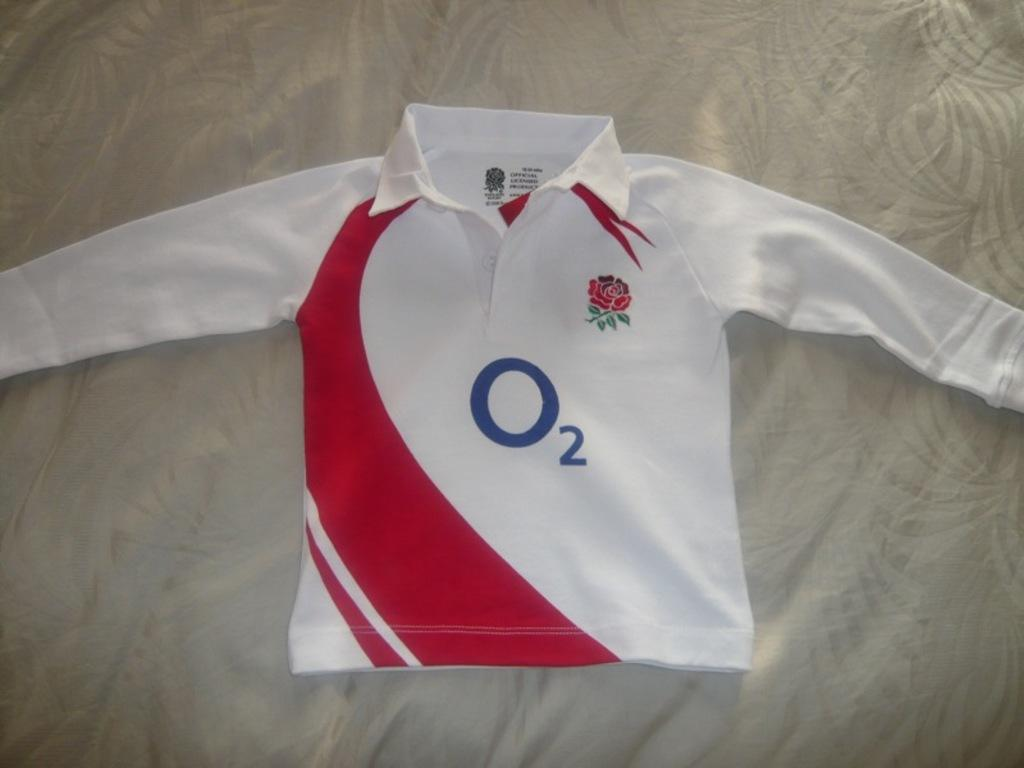Provide a one-sentence caption for the provided image. A child's long-sleeved white O2 England shirt, with red swooshing symbol up the left side, is laid out on a bed. 